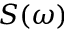<formula> <loc_0><loc_0><loc_500><loc_500>S ( \omega )</formula> 